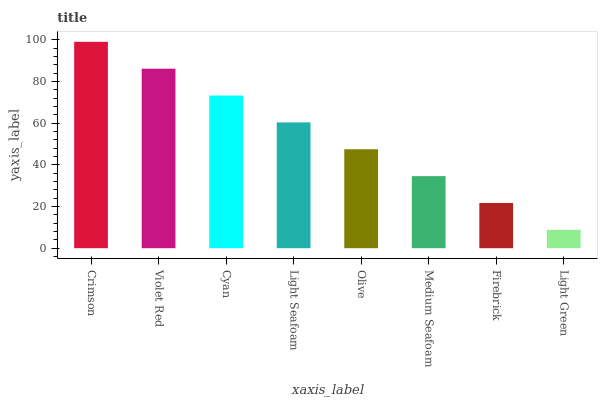Is Light Green the minimum?
Answer yes or no. Yes. Is Crimson the maximum?
Answer yes or no. Yes. Is Violet Red the minimum?
Answer yes or no. No. Is Violet Red the maximum?
Answer yes or no. No. Is Crimson greater than Violet Red?
Answer yes or no. Yes. Is Violet Red less than Crimson?
Answer yes or no. Yes. Is Violet Red greater than Crimson?
Answer yes or no. No. Is Crimson less than Violet Red?
Answer yes or no. No. Is Light Seafoam the high median?
Answer yes or no. Yes. Is Olive the low median?
Answer yes or no. Yes. Is Light Green the high median?
Answer yes or no. No. Is Light Green the low median?
Answer yes or no. No. 